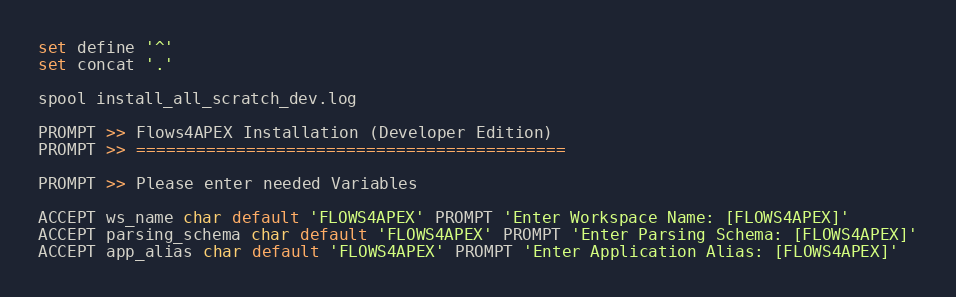<code> <loc_0><loc_0><loc_500><loc_500><_SQL_>set define '^'
set concat '.'

spool install_all_scratch_dev.log

PROMPT >> Flows4APEX Installation (Developer Edition)
PROMPT >> ===========================================

PROMPT >> Please enter needed Variables

ACCEPT ws_name char default 'FLOWS4APEX' PROMPT 'Enter Workspace Name: [FLOWS4APEX]'
ACCEPT parsing_schema char default 'FLOWS4APEX' PROMPT 'Enter Parsing Schema: [FLOWS4APEX]'
ACCEPT app_alias char default 'FLOWS4APEX' PROMPT 'Enter Application Alias: [FLOWS4APEX]'</code> 